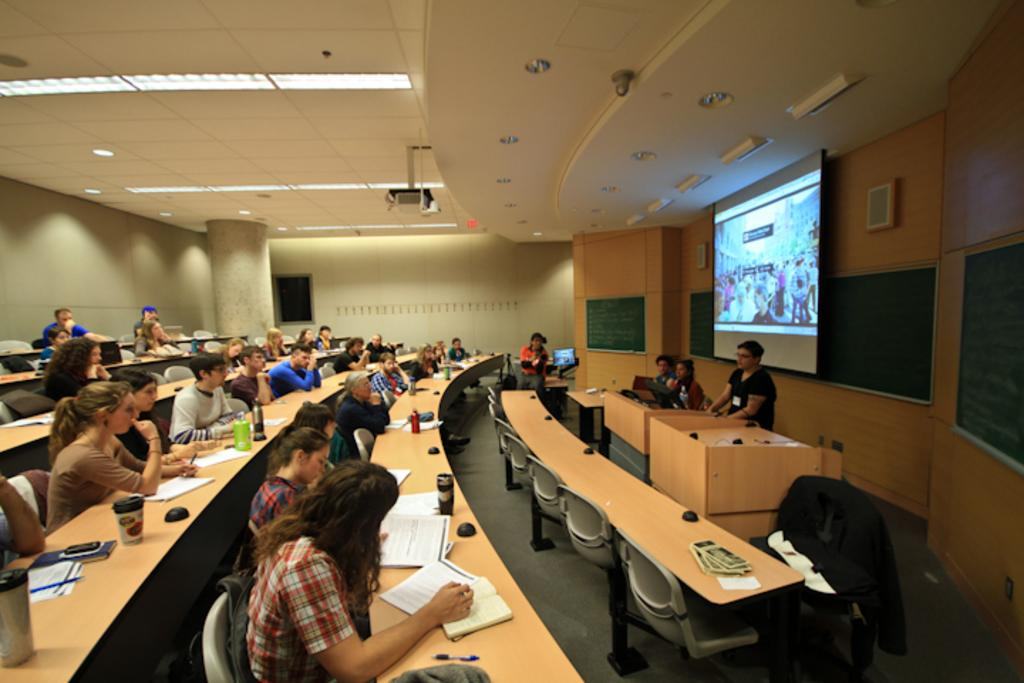What type of structure can be seen in the image? There is a wall in the image. What is the main object on the wall? There is a screen on the wall. What type of furniture is present in the image? There are tables and chairs in the image. What are the people in the image doing? There are people sitting on chairs in the image. What items can be seen on the tables? There are books, bottles, and a mobile phone on the tables in the image. Can you tell me how many secretaries are present in the image? There is no mention of a secretary in the image; it features a wall, a screen, tables, chairs, people sitting on chairs, books, bottles, and a mobile phone on the tables. Did the earthquake cause any damage to the items in the image? There is no indication of an earthquake or any damage in the image. 